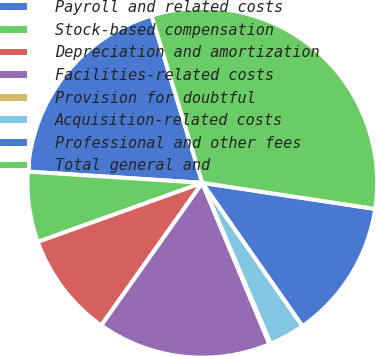Convert chart. <chart><loc_0><loc_0><loc_500><loc_500><pie_chart><fcel>Payroll and related costs<fcel>Stock-based compensation<fcel>Depreciation and amortization<fcel>Facilities-related costs<fcel>Provision for doubtful<fcel>Acquisition-related costs<fcel>Professional and other fees<fcel>Total general and<nl><fcel>19.29%<fcel>6.51%<fcel>9.7%<fcel>16.09%<fcel>0.12%<fcel>3.32%<fcel>12.9%<fcel>32.07%<nl></chart> 